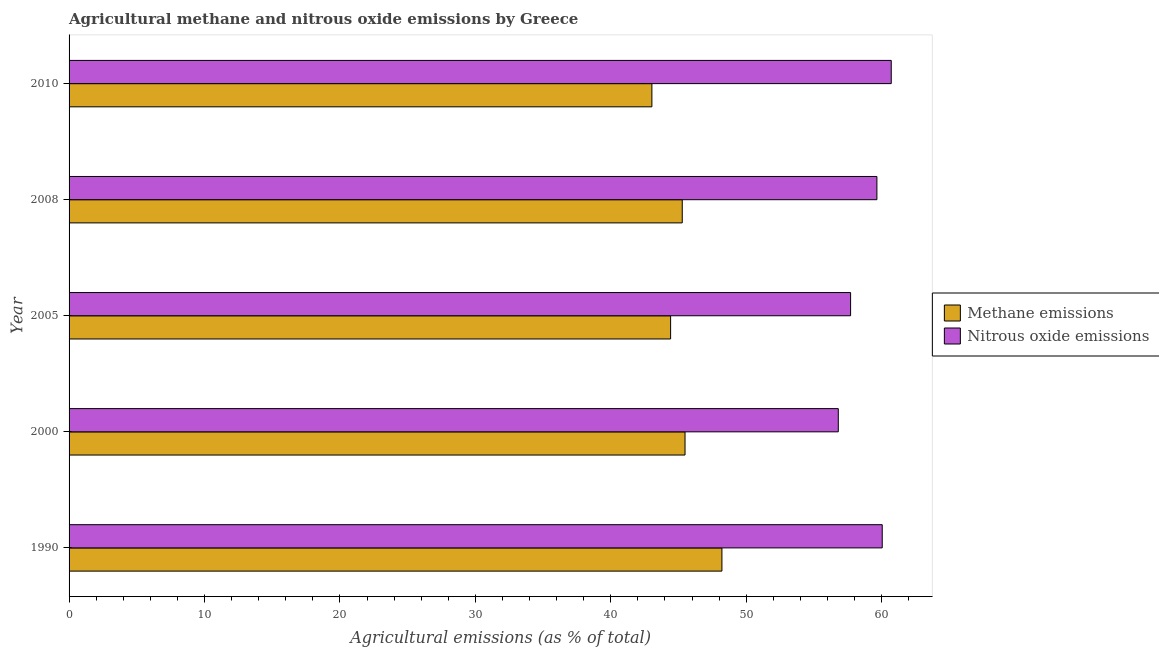In how many cases, is the number of bars for a given year not equal to the number of legend labels?
Keep it short and to the point. 0. What is the amount of nitrous oxide emissions in 1990?
Keep it short and to the point. 60.05. Across all years, what is the maximum amount of nitrous oxide emissions?
Offer a terse response. 60.71. Across all years, what is the minimum amount of nitrous oxide emissions?
Offer a terse response. 56.8. In which year was the amount of nitrous oxide emissions maximum?
Provide a succinct answer. 2010. In which year was the amount of methane emissions minimum?
Give a very brief answer. 2010. What is the total amount of nitrous oxide emissions in the graph?
Keep it short and to the point. 294.92. What is the difference between the amount of nitrous oxide emissions in 1990 and that in 2010?
Your answer should be compact. -0.67. What is the difference between the amount of methane emissions in 2000 and the amount of nitrous oxide emissions in 1990?
Offer a very short reply. -14.56. What is the average amount of methane emissions per year?
Keep it short and to the point. 45.29. In the year 2000, what is the difference between the amount of nitrous oxide emissions and amount of methane emissions?
Your answer should be very brief. 11.32. In how many years, is the amount of methane emissions greater than 46 %?
Make the answer very short. 1. What is the ratio of the amount of nitrous oxide emissions in 1990 to that in 2008?
Give a very brief answer. 1.01. Is the amount of methane emissions in 2005 less than that in 2010?
Provide a succinct answer. No. What is the difference between the highest and the second highest amount of methane emissions?
Your answer should be very brief. 2.72. What is the difference between the highest and the lowest amount of methane emissions?
Ensure brevity in your answer.  5.17. In how many years, is the amount of nitrous oxide emissions greater than the average amount of nitrous oxide emissions taken over all years?
Keep it short and to the point. 3. Is the sum of the amount of methane emissions in 2000 and 2008 greater than the maximum amount of nitrous oxide emissions across all years?
Give a very brief answer. Yes. What does the 2nd bar from the top in 2008 represents?
Offer a terse response. Methane emissions. What does the 1st bar from the bottom in 2000 represents?
Your response must be concise. Methane emissions. How many bars are there?
Give a very brief answer. 10. What is the difference between two consecutive major ticks on the X-axis?
Your answer should be very brief. 10. Are the values on the major ticks of X-axis written in scientific E-notation?
Your response must be concise. No. Does the graph contain grids?
Keep it short and to the point. No. Where does the legend appear in the graph?
Provide a short and direct response. Center right. How many legend labels are there?
Your response must be concise. 2. How are the legend labels stacked?
Offer a very short reply. Vertical. What is the title of the graph?
Keep it short and to the point. Agricultural methane and nitrous oxide emissions by Greece. What is the label or title of the X-axis?
Keep it short and to the point. Agricultural emissions (as % of total). What is the Agricultural emissions (as % of total) of Methane emissions in 1990?
Offer a terse response. 48.21. What is the Agricultural emissions (as % of total) in Nitrous oxide emissions in 1990?
Your answer should be compact. 60.05. What is the Agricultural emissions (as % of total) of Methane emissions in 2000?
Give a very brief answer. 45.48. What is the Agricultural emissions (as % of total) in Nitrous oxide emissions in 2000?
Keep it short and to the point. 56.8. What is the Agricultural emissions (as % of total) in Methane emissions in 2005?
Your answer should be compact. 44.42. What is the Agricultural emissions (as % of total) of Nitrous oxide emissions in 2005?
Your answer should be very brief. 57.71. What is the Agricultural emissions (as % of total) in Methane emissions in 2008?
Give a very brief answer. 45.28. What is the Agricultural emissions (as % of total) of Nitrous oxide emissions in 2008?
Offer a terse response. 59.65. What is the Agricultural emissions (as % of total) of Methane emissions in 2010?
Your response must be concise. 43.04. What is the Agricultural emissions (as % of total) of Nitrous oxide emissions in 2010?
Give a very brief answer. 60.71. Across all years, what is the maximum Agricultural emissions (as % of total) in Methane emissions?
Ensure brevity in your answer.  48.21. Across all years, what is the maximum Agricultural emissions (as % of total) of Nitrous oxide emissions?
Provide a succinct answer. 60.71. Across all years, what is the minimum Agricultural emissions (as % of total) in Methane emissions?
Your answer should be compact. 43.04. Across all years, what is the minimum Agricultural emissions (as % of total) in Nitrous oxide emissions?
Your response must be concise. 56.8. What is the total Agricultural emissions (as % of total) in Methane emissions in the graph?
Give a very brief answer. 226.43. What is the total Agricultural emissions (as % of total) of Nitrous oxide emissions in the graph?
Your answer should be very brief. 294.92. What is the difference between the Agricultural emissions (as % of total) in Methane emissions in 1990 and that in 2000?
Give a very brief answer. 2.72. What is the difference between the Agricultural emissions (as % of total) in Nitrous oxide emissions in 1990 and that in 2000?
Ensure brevity in your answer.  3.24. What is the difference between the Agricultural emissions (as % of total) in Methane emissions in 1990 and that in 2005?
Your answer should be very brief. 3.79. What is the difference between the Agricultural emissions (as % of total) of Nitrous oxide emissions in 1990 and that in 2005?
Your answer should be compact. 2.34. What is the difference between the Agricultural emissions (as % of total) in Methane emissions in 1990 and that in 2008?
Give a very brief answer. 2.93. What is the difference between the Agricultural emissions (as % of total) of Nitrous oxide emissions in 1990 and that in 2008?
Your answer should be very brief. 0.39. What is the difference between the Agricultural emissions (as % of total) of Methane emissions in 1990 and that in 2010?
Keep it short and to the point. 5.17. What is the difference between the Agricultural emissions (as % of total) of Nitrous oxide emissions in 1990 and that in 2010?
Your response must be concise. -0.67. What is the difference between the Agricultural emissions (as % of total) of Methane emissions in 2000 and that in 2005?
Make the answer very short. 1.06. What is the difference between the Agricultural emissions (as % of total) in Nitrous oxide emissions in 2000 and that in 2005?
Your answer should be compact. -0.91. What is the difference between the Agricultural emissions (as % of total) in Methane emissions in 2000 and that in 2008?
Your response must be concise. 0.2. What is the difference between the Agricultural emissions (as % of total) of Nitrous oxide emissions in 2000 and that in 2008?
Keep it short and to the point. -2.85. What is the difference between the Agricultural emissions (as % of total) in Methane emissions in 2000 and that in 2010?
Offer a terse response. 2.45. What is the difference between the Agricultural emissions (as % of total) in Nitrous oxide emissions in 2000 and that in 2010?
Provide a short and direct response. -3.91. What is the difference between the Agricultural emissions (as % of total) of Methane emissions in 2005 and that in 2008?
Provide a short and direct response. -0.86. What is the difference between the Agricultural emissions (as % of total) of Nitrous oxide emissions in 2005 and that in 2008?
Keep it short and to the point. -1.94. What is the difference between the Agricultural emissions (as % of total) in Methane emissions in 2005 and that in 2010?
Give a very brief answer. 1.38. What is the difference between the Agricultural emissions (as % of total) of Nitrous oxide emissions in 2005 and that in 2010?
Provide a succinct answer. -3. What is the difference between the Agricultural emissions (as % of total) in Methane emissions in 2008 and that in 2010?
Your answer should be very brief. 2.24. What is the difference between the Agricultural emissions (as % of total) of Nitrous oxide emissions in 2008 and that in 2010?
Your answer should be very brief. -1.06. What is the difference between the Agricultural emissions (as % of total) in Methane emissions in 1990 and the Agricultural emissions (as % of total) in Nitrous oxide emissions in 2000?
Offer a terse response. -8.59. What is the difference between the Agricultural emissions (as % of total) of Methane emissions in 1990 and the Agricultural emissions (as % of total) of Nitrous oxide emissions in 2005?
Offer a terse response. -9.5. What is the difference between the Agricultural emissions (as % of total) of Methane emissions in 1990 and the Agricultural emissions (as % of total) of Nitrous oxide emissions in 2008?
Offer a terse response. -11.44. What is the difference between the Agricultural emissions (as % of total) in Methane emissions in 1990 and the Agricultural emissions (as % of total) in Nitrous oxide emissions in 2010?
Offer a terse response. -12.5. What is the difference between the Agricultural emissions (as % of total) in Methane emissions in 2000 and the Agricultural emissions (as % of total) in Nitrous oxide emissions in 2005?
Provide a succinct answer. -12.23. What is the difference between the Agricultural emissions (as % of total) of Methane emissions in 2000 and the Agricultural emissions (as % of total) of Nitrous oxide emissions in 2008?
Keep it short and to the point. -14.17. What is the difference between the Agricultural emissions (as % of total) of Methane emissions in 2000 and the Agricultural emissions (as % of total) of Nitrous oxide emissions in 2010?
Your response must be concise. -15.23. What is the difference between the Agricultural emissions (as % of total) of Methane emissions in 2005 and the Agricultural emissions (as % of total) of Nitrous oxide emissions in 2008?
Your answer should be compact. -15.23. What is the difference between the Agricultural emissions (as % of total) in Methane emissions in 2005 and the Agricultural emissions (as % of total) in Nitrous oxide emissions in 2010?
Make the answer very short. -16.29. What is the difference between the Agricultural emissions (as % of total) in Methane emissions in 2008 and the Agricultural emissions (as % of total) in Nitrous oxide emissions in 2010?
Provide a succinct answer. -15.43. What is the average Agricultural emissions (as % of total) in Methane emissions per year?
Your answer should be compact. 45.29. What is the average Agricultural emissions (as % of total) of Nitrous oxide emissions per year?
Provide a short and direct response. 58.98. In the year 1990, what is the difference between the Agricultural emissions (as % of total) in Methane emissions and Agricultural emissions (as % of total) in Nitrous oxide emissions?
Provide a succinct answer. -11.84. In the year 2000, what is the difference between the Agricultural emissions (as % of total) of Methane emissions and Agricultural emissions (as % of total) of Nitrous oxide emissions?
Give a very brief answer. -11.32. In the year 2005, what is the difference between the Agricultural emissions (as % of total) in Methane emissions and Agricultural emissions (as % of total) in Nitrous oxide emissions?
Your response must be concise. -13.29. In the year 2008, what is the difference between the Agricultural emissions (as % of total) in Methane emissions and Agricultural emissions (as % of total) in Nitrous oxide emissions?
Your answer should be compact. -14.37. In the year 2010, what is the difference between the Agricultural emissions (as % of total) in Methane emissions and Agricultural emissions (as % of total) in Nitrous oxide emissions?
Offer a terse response. -17.67. What is the ratio of the Agricultural emissions (as % of total) in Methane emissions in 1990 to that in 2000?
Offer a very short reply. 1.06. What is the ratio of the Agricultural emissions (as % of total) in Nitrous oxide emissions in 1990 to that in 2000?
Ensure brevity in your answer.  1.06. What is the ratio of the Agricultural emissions (as % of total) in Methane emissions in 1990 to that in 2005?
Your answer should be very brief. 1.09. What is the ratio of the Agricultural emissions (as % of total) of Nitrous oxide emissions in 1990 to that in 2005?
Provide a succinct answer. 1.04. What is the ratio of the Agricultural emissions (as % of total) in Methane emissions in 1990 to that in 2008?
Your answer should be compact. 1.06. What is the ratio of the Agricultural emissions (as % of total) of Nitrous oxide emissions in 1990 to that in 2008?
Offer a terse response. 1.01. What is the ratio of the Agricultural emissions (as % of total) of Methane emissions in 1990 to that in 2010?
Provide a succinct answer. 1.12. What is the ratio of the Agricultural emissions (as % of total) in Nitrous oxide emissions in 1990 to that in 2010?
Provide a short and direct response. 0.99. What is the ratio of the Agricultural emissions (as % of total) of Nitrous oxide emissions in 2000 to that in 2005?
Keep it short and to the point. 0.98. What is the ratio of the Agricultural emissions (as % of total) of Nitrous oxide emissions in 2000 to that in 2008?
Make the answer very short. 0.95. What is the ratio of the Agricultural emissions (as % of total) in Methane emissions in 2000 to that in 2010?
Offer a very short reply. 1.06. What is the ratio of the Agricultural emissions (as % of total) of Nitrous oxide emissions in 2000 to that in 2010?
Give a very brief answer. 0.94. What is the ratio of the Agricultural emissions (as % of total) in Nitrous oxide emissions in 2005 to that in 2008?
Ensure brevity in your answer.  0.97. What is the ratio of the Agricultural emissions (as % of total) of Methane emissions in 2005 to that in 2010?
Provide a succinct answer. 1.03. What is the ratio of the Agricultural emissions (as % of total) of Nitrous oxide emissions in 2005 to that in 2010?
Keep it short and to the point. 0.95. What is the ratio of the Agricultural emissions (as % of total) in Methane emissions in 2008 to that in 2010?
Keep it short and to the point. 1.05. What is the ratio of the Agricultural emissions (as % of total) of Nitrous oxide emissions in 2008 to that in 2010?
Make the answer very short. 0.98. What is the difference between the highest and the second highest Agricultural emissions (as % of total) of Methane emissions?
Give a very brief answer. 2.72. What is the difference between the highest and the second highest Agricultural emissions (as % of total) of Nitrous oxide emissions?
Ensure brevity in your answer.  0.67. What is the difference between the highest and the lowest Agricultural emissions (as % of total) in Methane emissions?
Offer a very short reply. 5.17. What is the difference between the highest and the lowest Agricultural emissions (as % of total) of Nitrous oxide emissions?
Give a very brief answer. 3.91. 